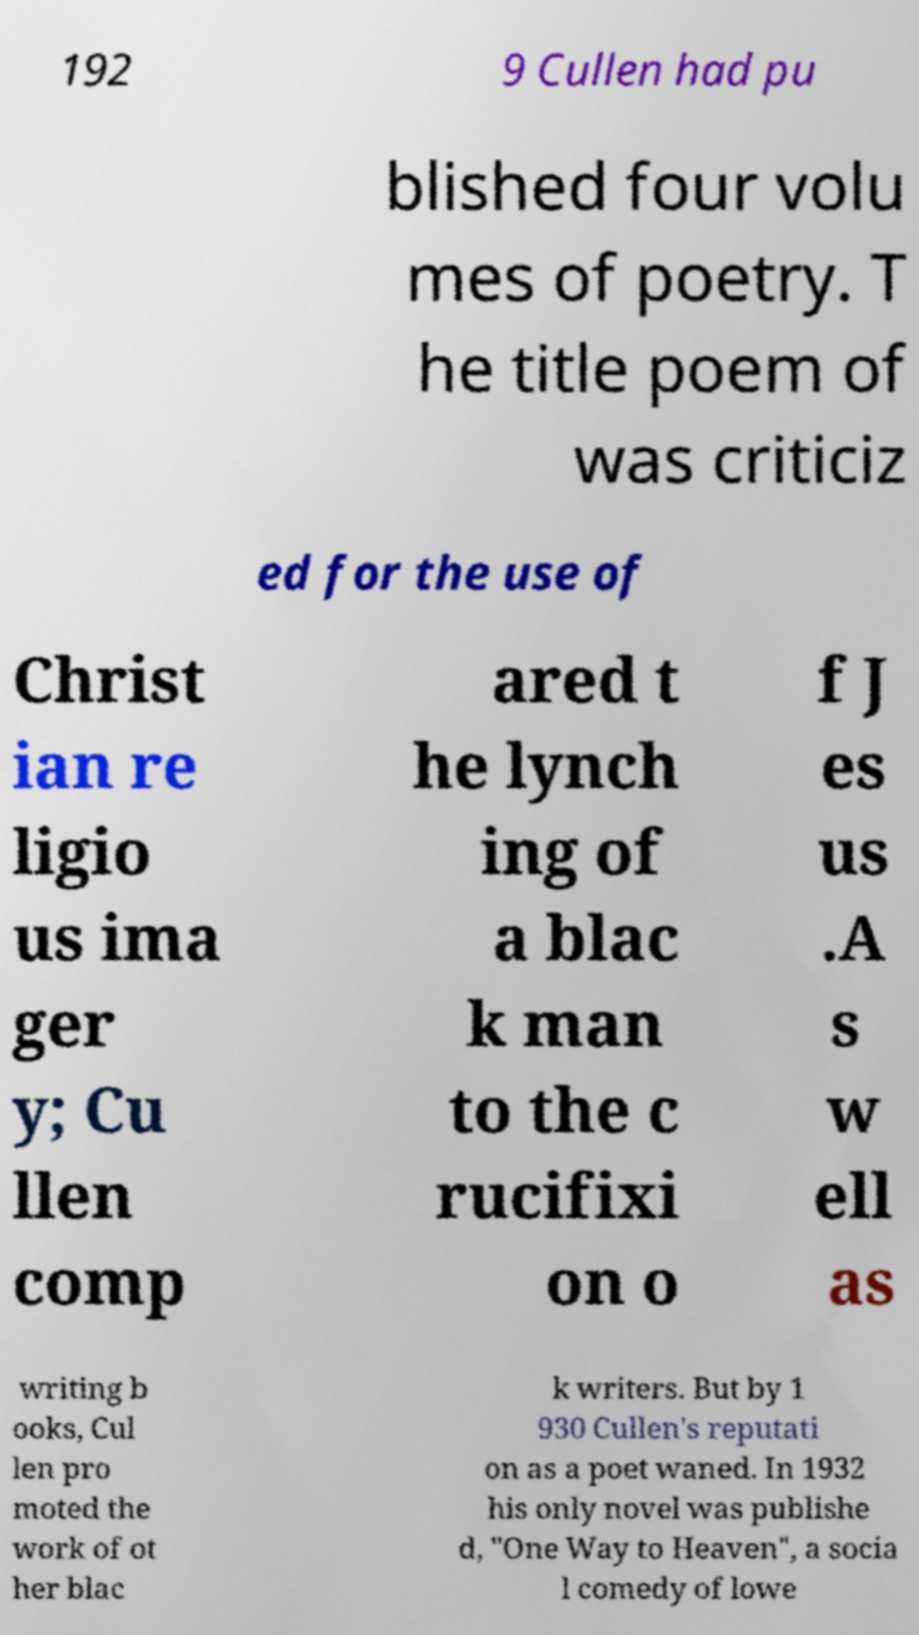Could you assist in decoding the text presented in this image and type it out clearly? 192 9 Cullen had pu blished four volu mes of poetry. T he title poem of was criticiz ed for the use of Christ ian re ligio us ima ger y; Cu llen comp ared t he lynch ing of a blac k man to the c rucifixi on o f J es us .A s w ell as writing b ooks, Cul len pro moted the work of ot her blac k writers. But by 1 930 Cullen's reputati on as a poet waned. In 1932 his only novel was publishe d, "One Way to Heaven", a socia l comedy of lowe 